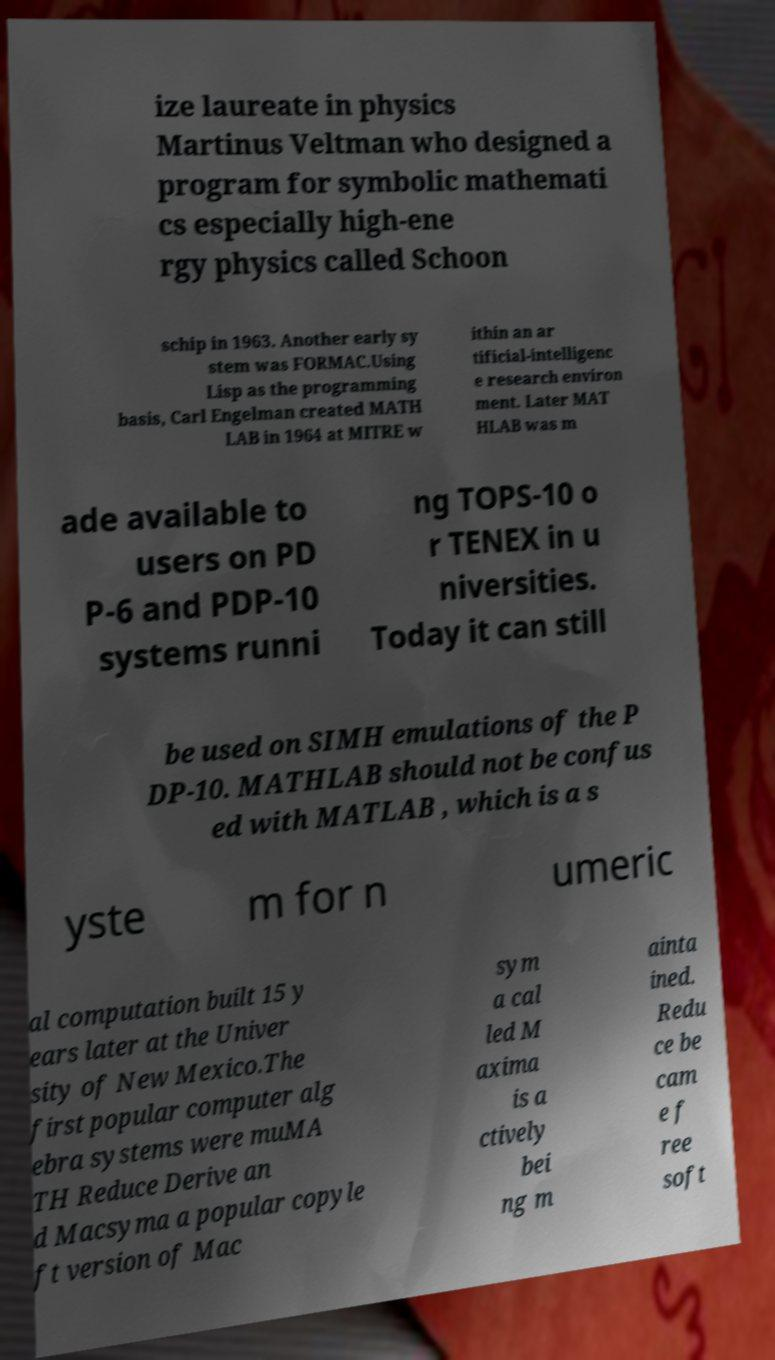Could you assist in decoding the text presented in this image and type it out clearly? ize laureate in physics Martinus Veltman who designed a program for symbolic mathemati cs especially high-ene rgy physics called Schoon schip in 1963. Another early sy stem was FORMAC.Using Lisp as the programming basis, Carl Engelman created MATH LAB in 1964 at MITRE w ithin an ar tificial-intelligenc e research environ ment. Later MAT HLAB was m ade available to users on PD P-6 and PDP-10 systems runni ng TOPS-10 o r TENEX in u niversities. Today it can still be used on SIMH emulations of the P DP-10. MATHLAB should not be confus ed with MATLAB , which is a s yste m for n umeric al computation built 15 y ears later at the Univer sity of New Mexico.The first popular computer alg ebra systems were muMA TH Reduce Derive an d Macsyma a popular copyle ft version of Mac sym a cal led M axima is a ctively bei ng m ainta ined. Redu ce be cam e f ree soft 